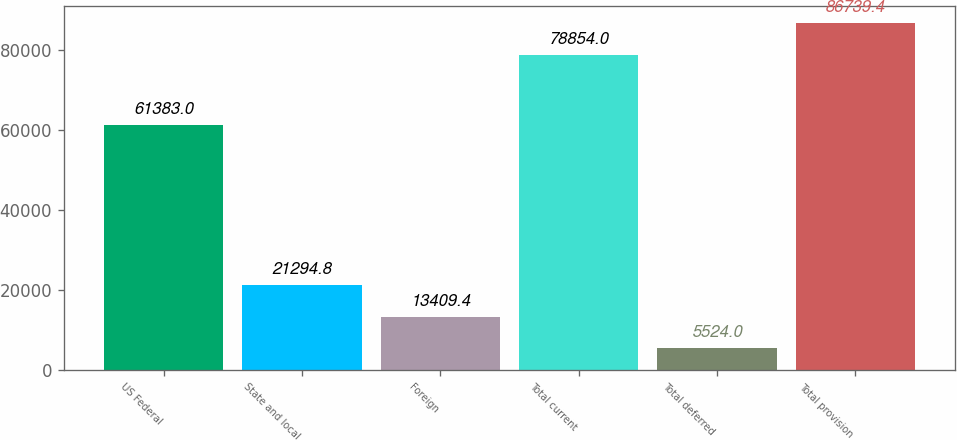<chart> <loc_0><loc_0><loc_500><loc_500><bar_chart><fcel>US Federal<fcel>State and local<fcel>Foreign<fcel>Total current<fcel>Total deferred<fcel>Total provision<nl><fcel>61383<fcel>21294.8<fcel>13409.4<fcel>78854<fcel>5524<fcel>86739.4<nl></chart> 